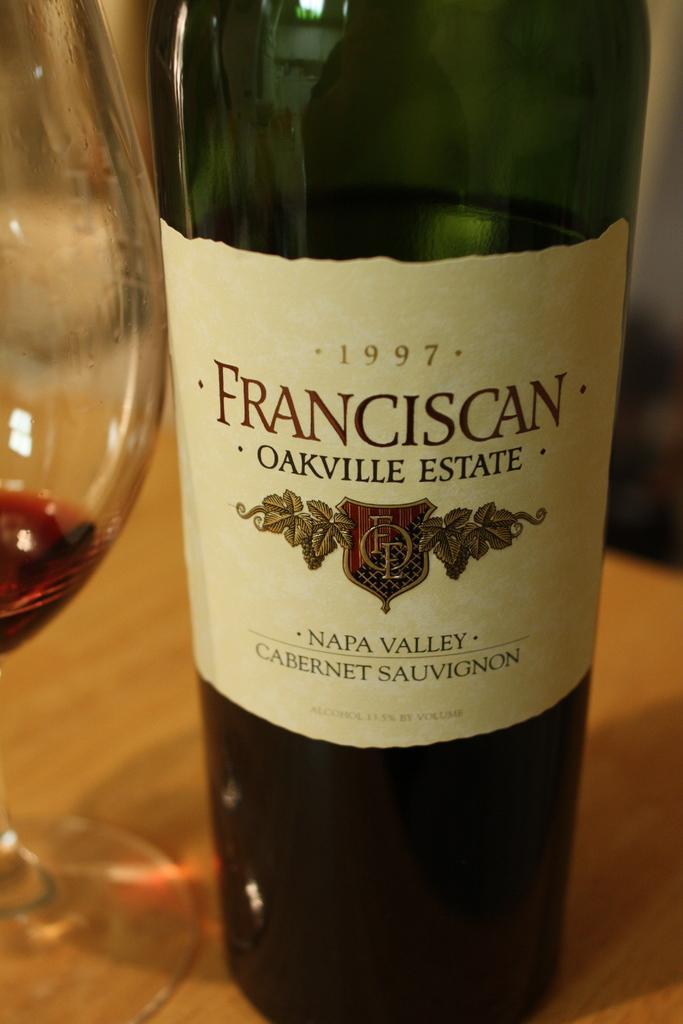Describe this image in one or two sentences. In this image I can see a bottle and a glass on the table. 